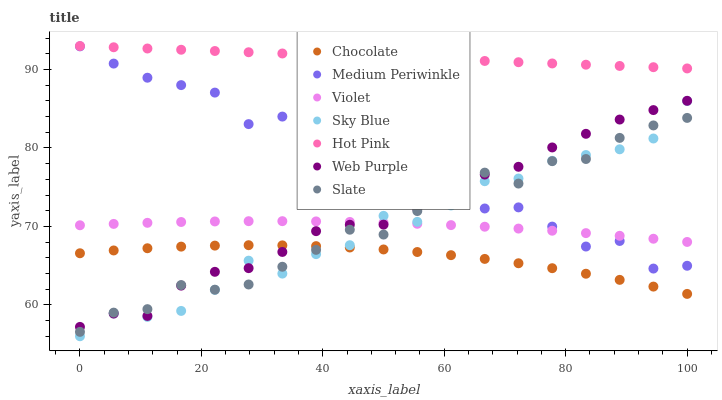Does Chocolate have the minimum area under the curve?
Answer yes or no. Yes. Does Hot Pink have the maximum area under the curve?
Answer yes or no. Yes. Does Medium Periwinkle have the minimum area under the curve?
Answer yes or no. No. Does Medium Periwinkle have the maximum area under the curve?
Answer yes or no. No. Is Hot Pink the smoothest?
Answer yes or no. Yes. Is Sky Blue the roughest?
Answer yes or no. Yes. Is Medium Periwinkle the smoothest?
Answer yes or no. No. Is Medium Periwinkle the roughest?
Answer yes or no. No. Does Sky Blue have the lowest value?
Answer yes or no. Yes. Does Medium Periwinkle have the lowest value?
Answer yes or no. No. Does Hot Pink have the highest value?
Answer yes or no. Yes. Does Medium Periwinkle have the highest value?
Answer yes or no. No. Is Sky Blue less than Hot Pink?
Answer yes or no. Yes. Is Hot Pink greater than Chocolate?
Answer yes or no. Yes. Does Medium Periwinkle intersect Violet?
Answer yes or no. Yes. Is Medium Periwinkle less than Violet?
Answer yes or no. No. Is Medium Periwinkle greater than Violet?
Answer yes or no. No. Does Sky Blue intersect Hot Pink?
Answer yes or no. No. 